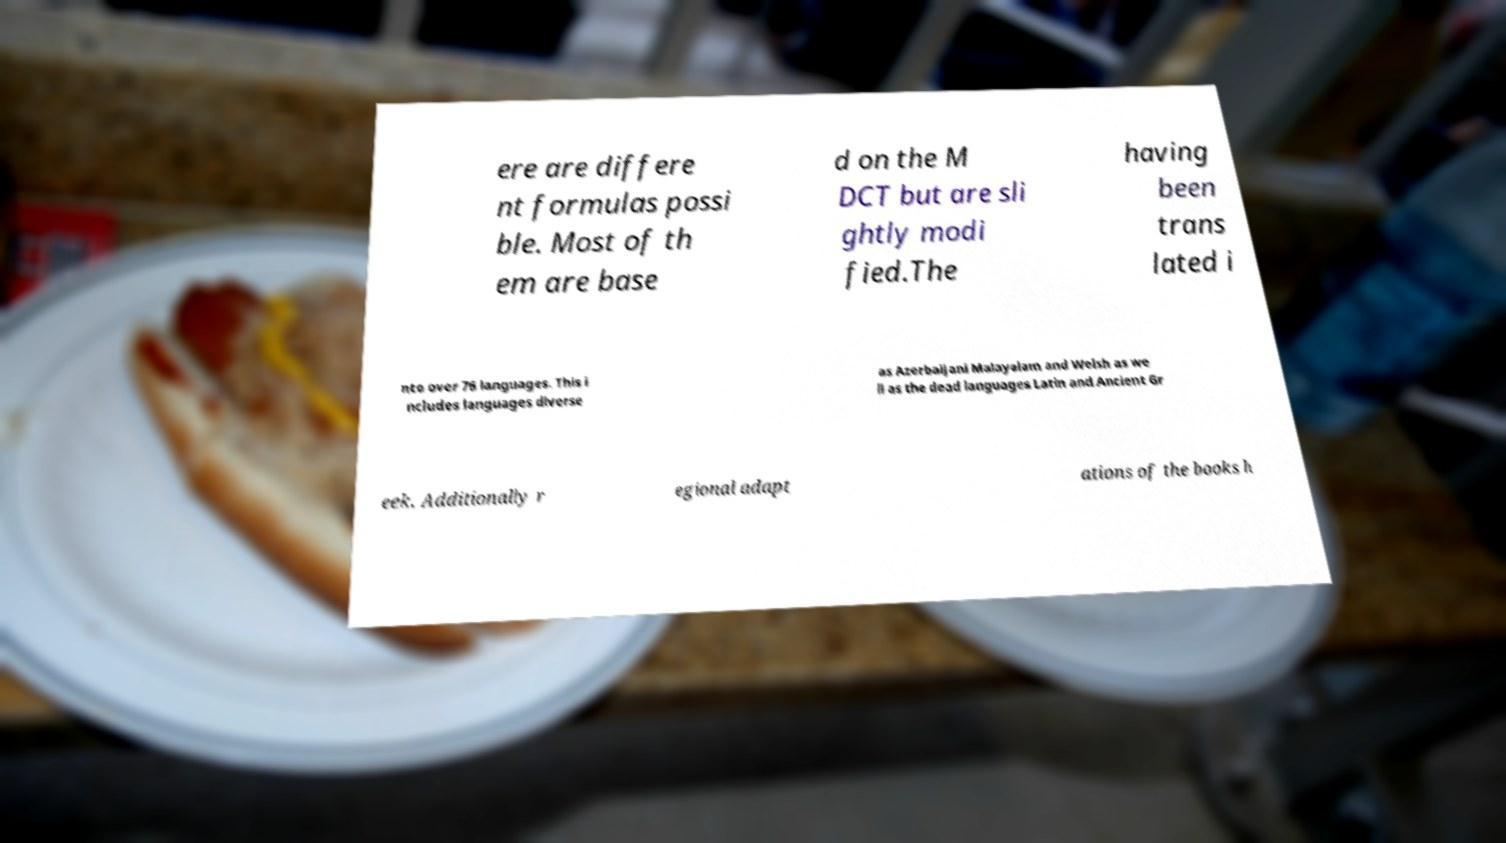Please read and relay the text visible in this image. What does it say? ere are differe nt formulas possi ble. Most of th em are base d on the M DCT but are sli ghtly modi fied.The having been trans lated i nto over 76 languages. This i ncludes languages diverse as Azerbaijani Malayalam and Welsh as we ll as the dead languages Latin and Ancient Gr eek. Additionally r egional adapt ations of the books h 